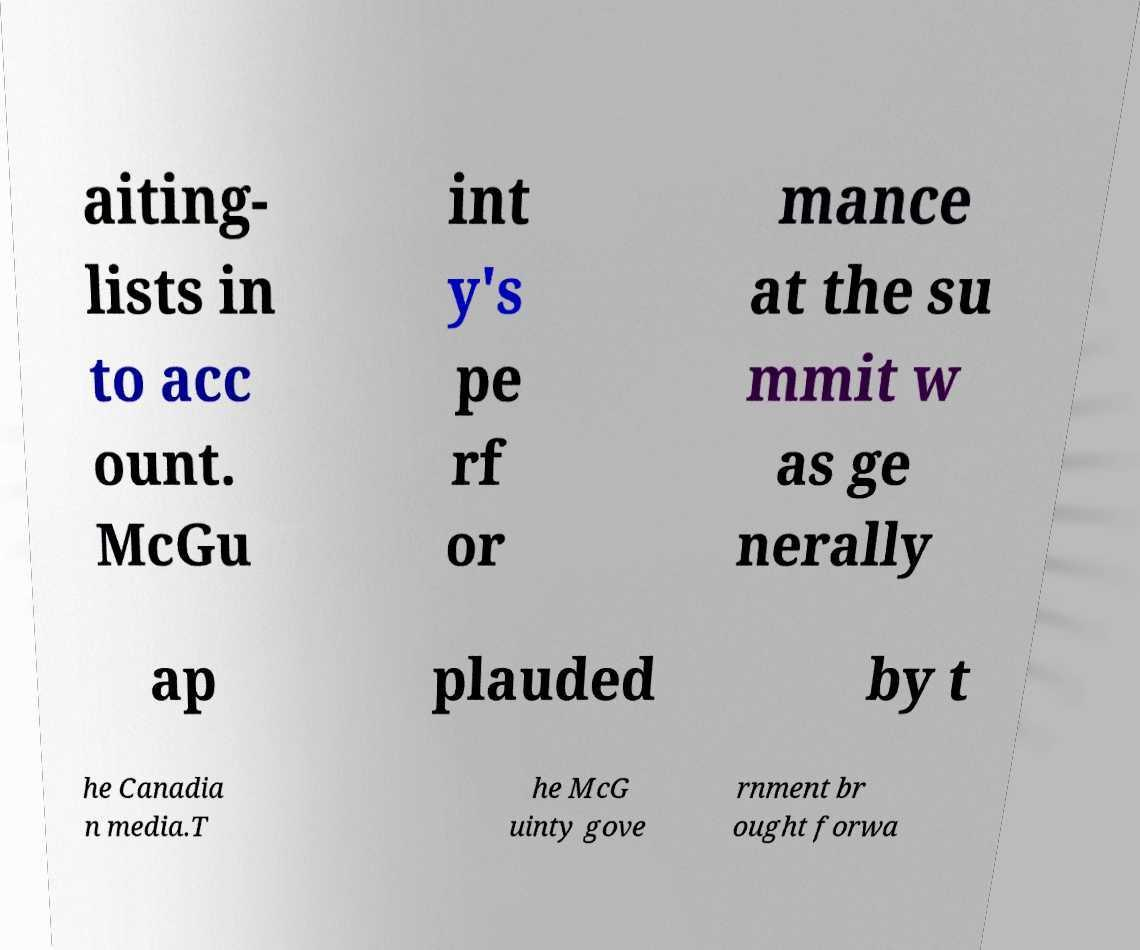Can you read and provide the text displayed in the image?This photo seems to have some interesting text. Can you extract and type it out for me? aiting- lists in to acc ount. McGu int y's pe rf or mance at the su mmit w as ge nerally ap plauded by t he Canadia n media.T he McG uinty gove rnment br ought forwa 